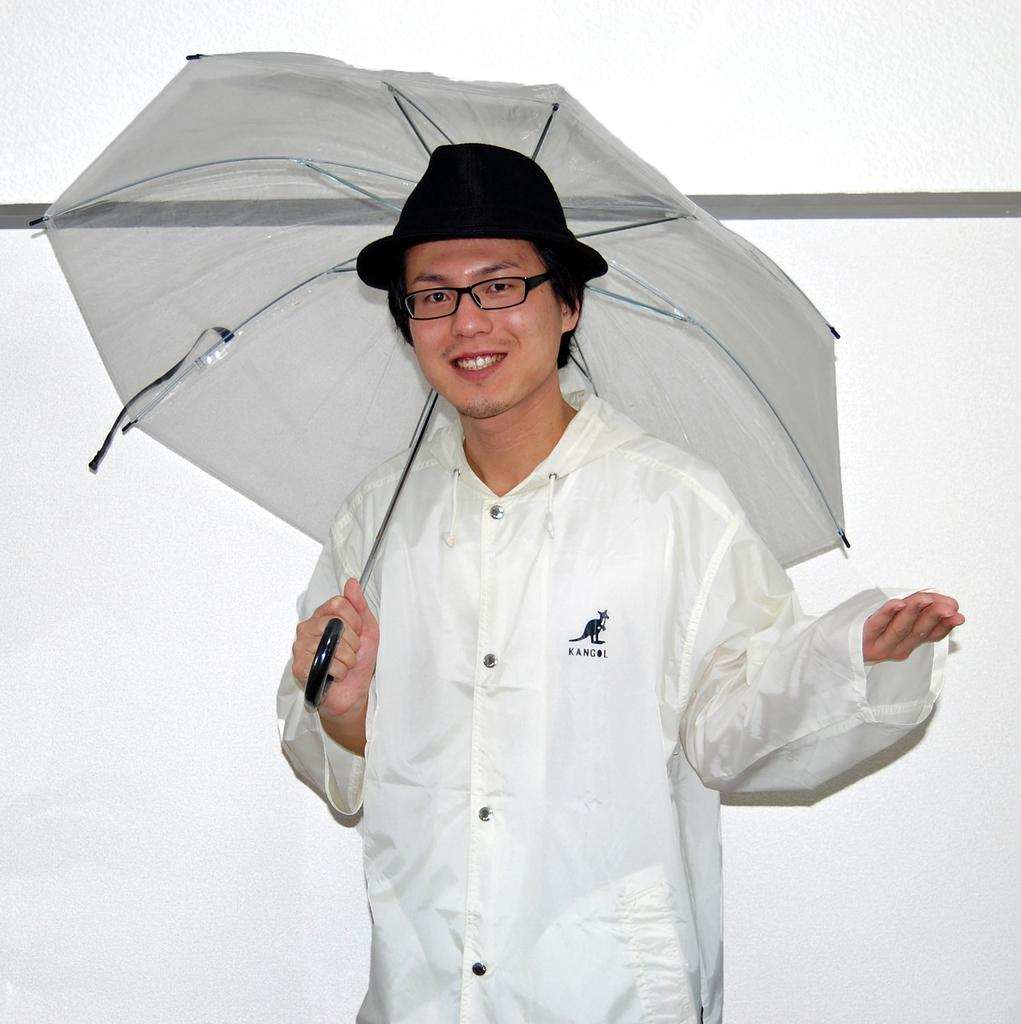What is the man in the image doing? The man is standing in the image. What is the man's facial expression? The man is smiling. What object is the man holding in the image? The man is holding an umbrella. What accessories is the man wearing in the image? The man is wearing spectacles and a hat. What can be seen behind the man in the image? There is a white wall visible behind the man. How many ladybugs are crawling on the floor in the image? There are no ladybugs visible in the image, and the floor is not mentioned in the provided facts. What type of slave is depicted in the image? There is no depiction of a slave in the image; it features a man standing with an umbrella. 